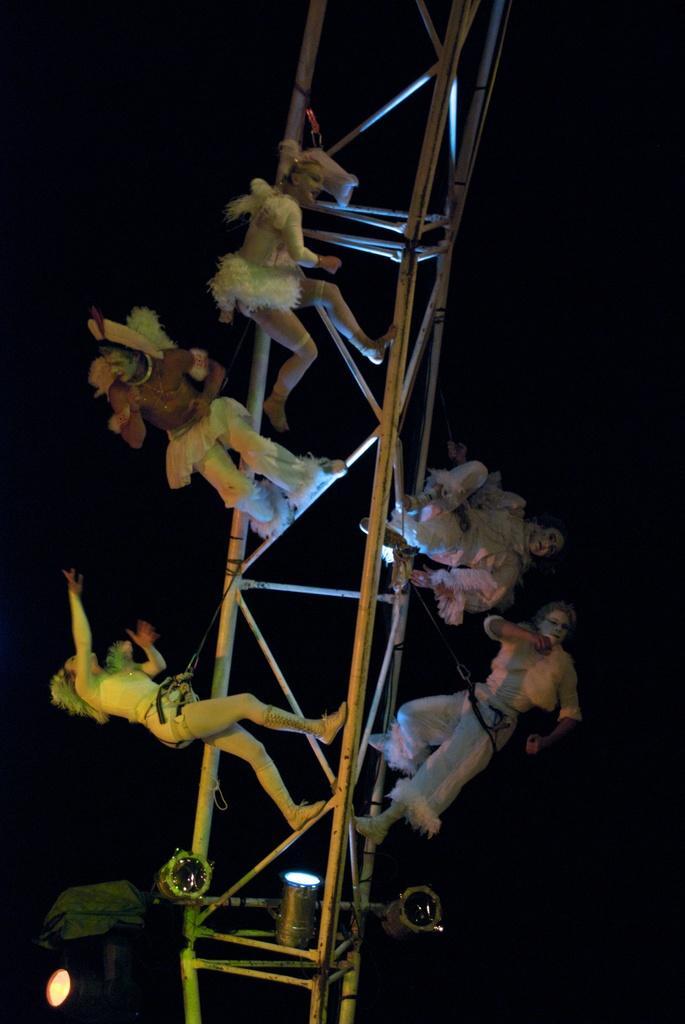Describe this image in one or two sentences. In this image we can see person holding the metal frame. 